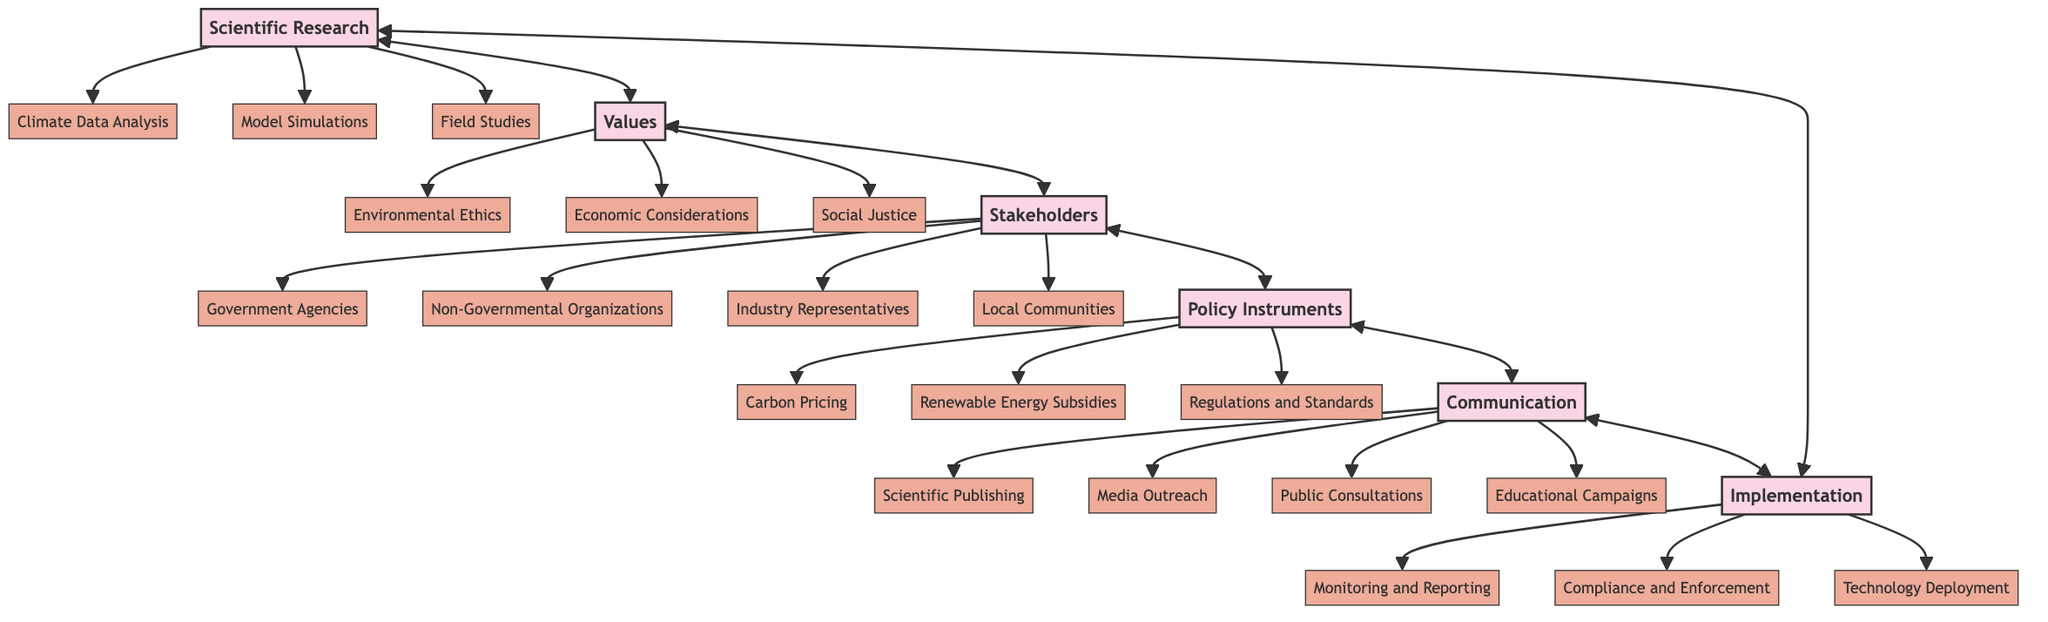What are the sub-elements of Scientific Research? The diagram outlines three sub-elements connected to the "Scientific Research" main node: "Climate Data Analysis," "Model Simulations," and "Field Studies." These are visually represented as branching from the main node.
Answer: Climate Data Analysis, Model Simulations, Field Studies How many main nodes are in the diagram? The diagram visually represents six main nodes: "Scientific Research," "Values," "Stakeholders," "Policy Instruments," "Communication," and "Implementation." This can be counted directly from the diagram.
Answer: 6 Which main node has the sub-element "Social Justice"? The node labeled "Values" has "Social Justice" as one of its sub-elements. This is identified by reviewing the connections in the diagram from "Values" to its corresponding sub-level.
Answer: Values What is the relationship between Stakeholders and Policy Instruments? The relationship is mutual, indicated by the double-headed arrow connecting "Stakeholders" and "Policy Instruments." This signifies that they influence each other in terms of climate policies, as depicted in the diagram.
Answer: Mutual influence How many sub-elements does Communication have? The "Communication" node has four sub-elements listed: "Scientific Publishing," "Media Outreach," "Public Consultations," and "Educational Campaigns." Counting these branches confirms the total number.
Answer: 4 What are the values that influence policy decisions? The sub-elements under the "Values" node include "Environmental Ethics," "Economic Considerations," and "Social Justice." These specific values are depicted as branches under the "Values" main node.
Answer: Environmental Ethics, Economic Considerations, Social Justice How does Implementation relate to Scientific Research? There is a direct relationship indicated by a two-way arrow connecting "Implementation" and "Scientific Research," signifying that findings from scientific research influence policy implementation, and vice versa.
Answer: Direct relationship What is one example of a Policy Instrument from the diagram? The sub-element "Carbon Pricing" is one example of a policy instrument shown in the diagram, which branches from the "Policy Instruments" main node. This can be identified visually from the diagram.
Answer: Carbon Pricing 